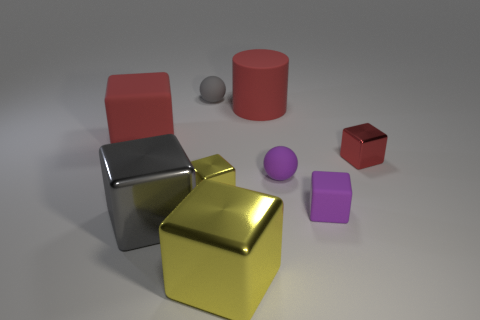Subtract all big yellow metal cubes. How many cubes are left? 5 Subtract all red cylinders. How many yellow blocks are left? 2 Subtract 2 cubes. How many cubes are left? 4 Subtract all purple cubes. How many cubes are left? 5 Add 1 yellow metal balls. How many objects exist? 10 Subtract all yellow blocks. Subtract all cyan cylinders. How many blocks are left? 4 Subtract all cylinders. How many objects are left? 8 Add 2 brown shiny blocks. How many brown shiny blocks exist? 2 Subtract 0 brown cylinders. How many objects are left? 9 Subtract all small rubber blocks. Subtract all small spheres. How many objects are left? 6 